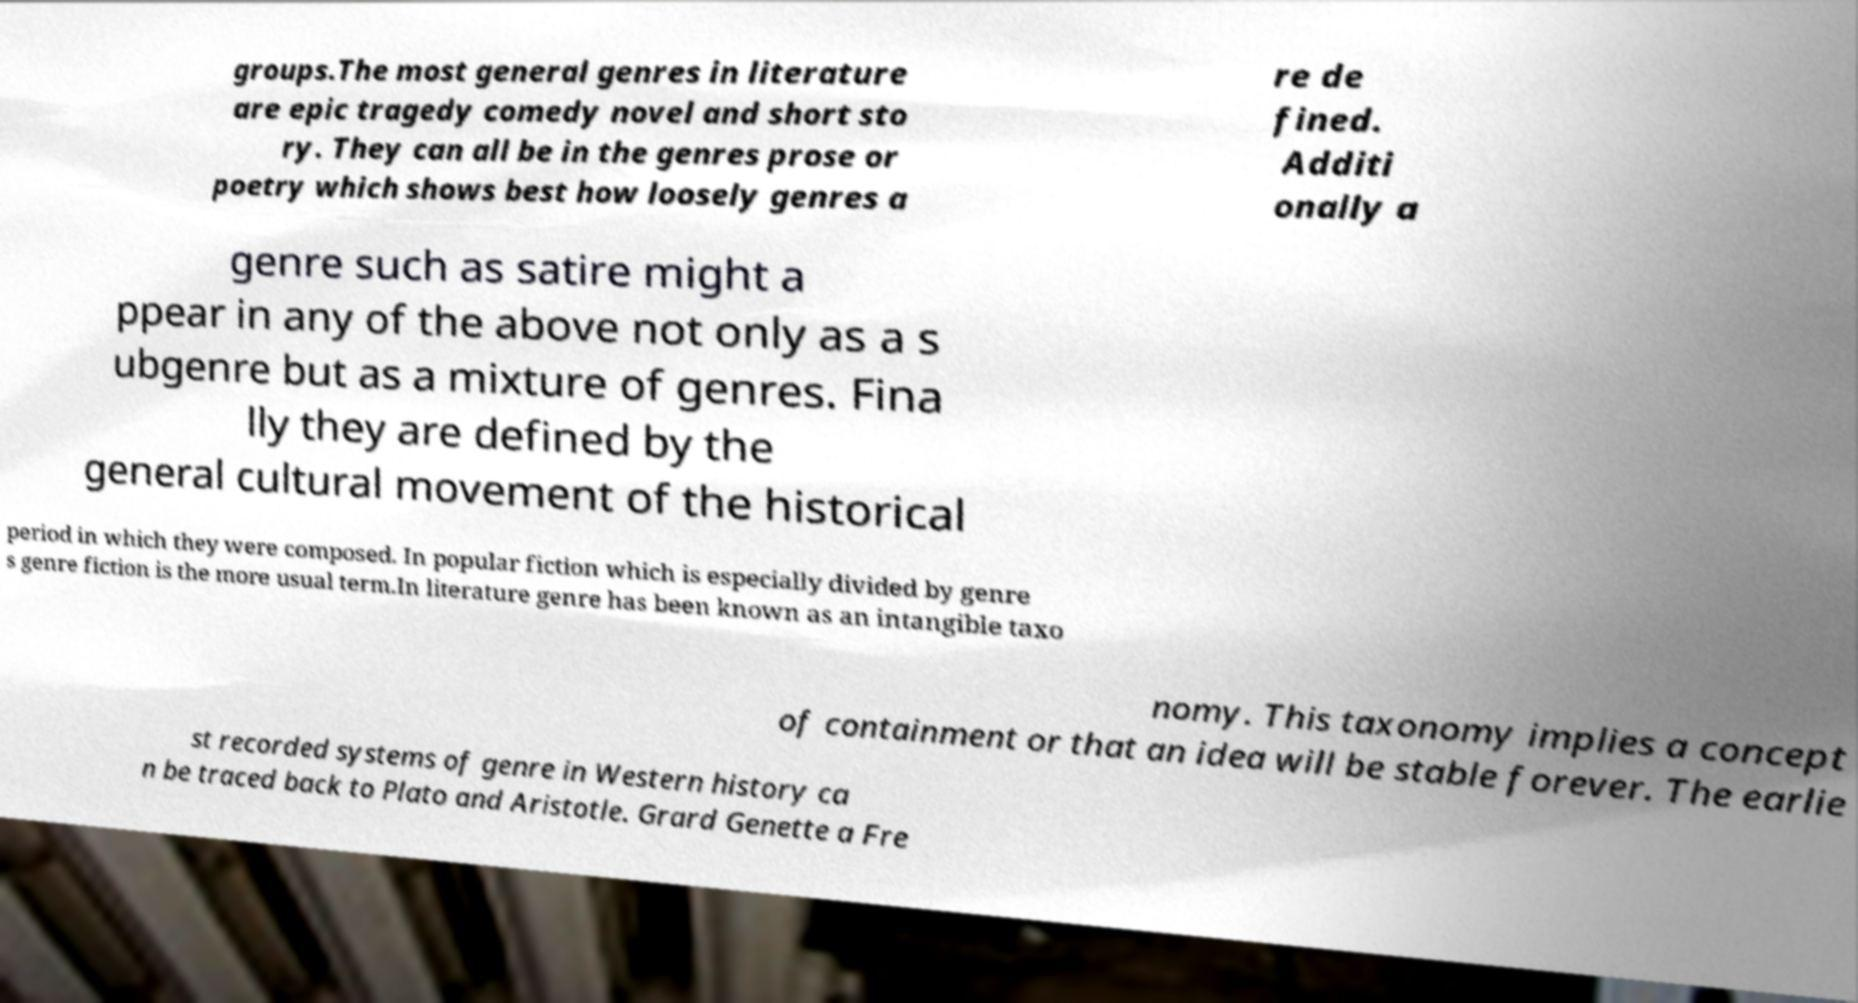Could you extract and type out the text from this image? groups.The most general genres in literature are epic tragedy comedy novel and short sto ry. They can all be in the genres prose or poetry which shows best how loosely genres a re de fined. Additi onally a genre such as satire might a ppear in any of the above not only as a s ubgenre but as a mixture of genres. Fina lly they are defined by the general cultural movement of the historical period in which they were composed. In popular fiction which is especially divided by genre s genre fiction is the more usual term.In literature genre has been known as an intangible taxo nomy. This taxonomy implies a concept of containment or that an idea will be stable forever. The earlie st recorded systems of genre in Western history ca n be traced back to Plato and Aristotle. Grard Genette a Fre 